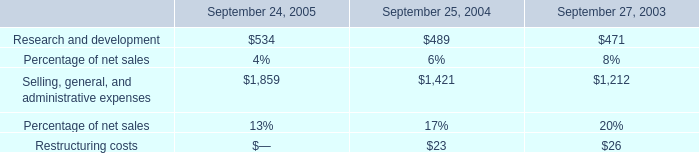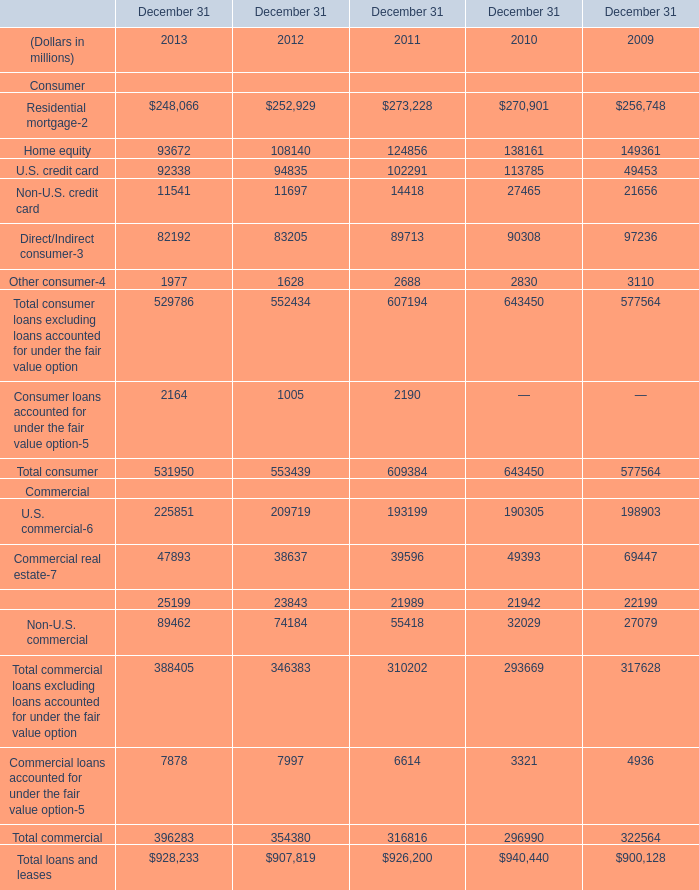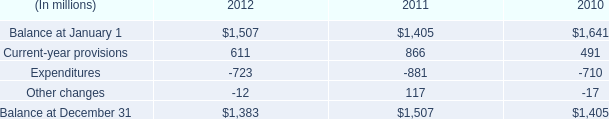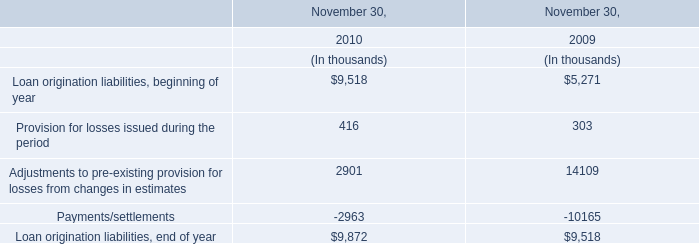what's the total amount of Selling, general, and administrative expenses of September 25, 2004, and Commercial real estate Commercial of December 31 2009 ? 
Computations: (1421.0 + 69447.0)
Answer: 70868.0. 